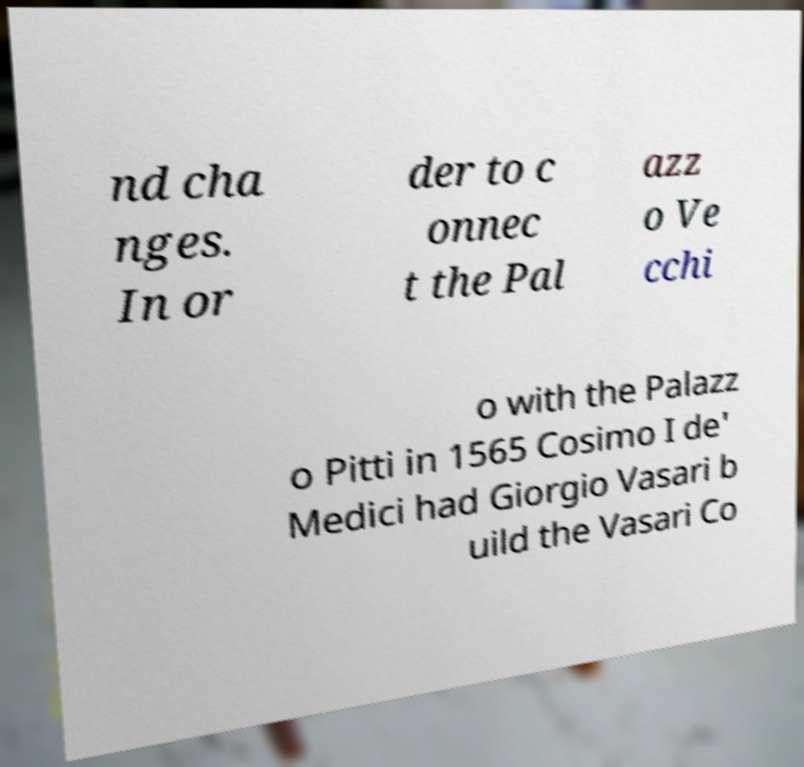For documentation purposes, I need the text within this image transcribed. Could you provide that? nd cha nges. In or der to c onnec t the Pal azz o Ve cchi o with the Palazz o Pitti in 1565 Cosimo I de' Medici had Giorgio Vasari b uild the Vasari Co 